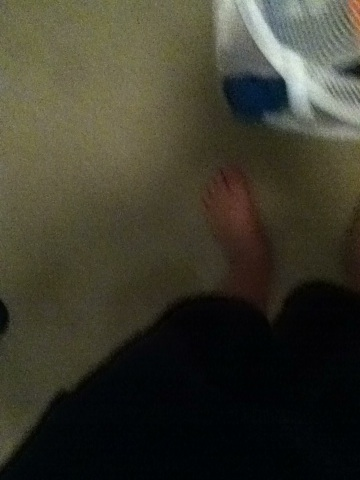Can you describe what is happening in this image? The image shows a person's bare feet and lower legs standing on what appears to be a carpeted floor. There's a white plastic basket beside their feet that contains some blue and possibly other colored clothing or items. Where do you think this could be? This image could have been taken in a bedroom or a laundry room. The presence of a basket with clothing suggests it could be a place where personal belongings are kept or sorted, like a closet or a personal living space. 